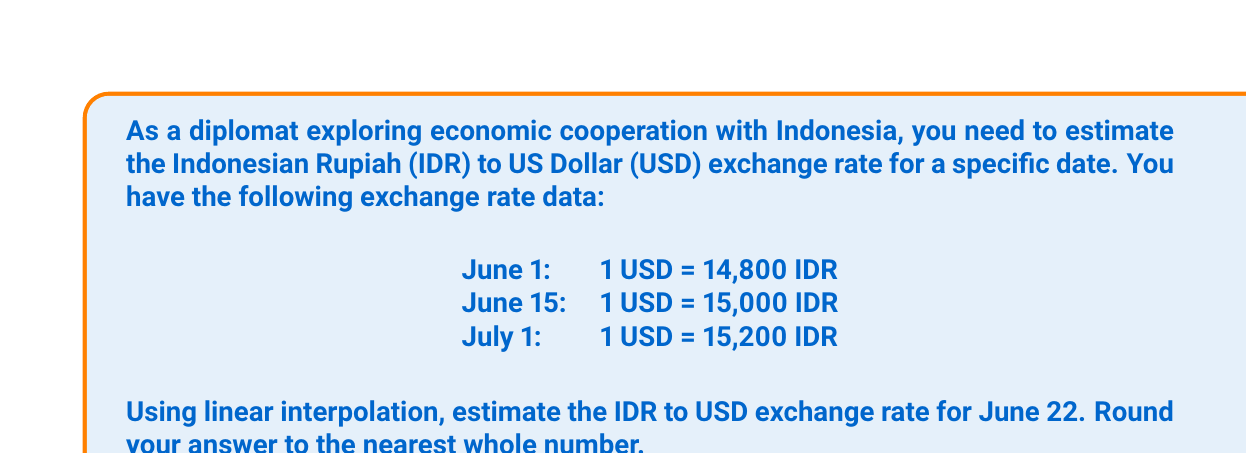Could you help me with this problem? To solve this problem, we'll use linear interpolation. The formula for linear interpolation is:

$$f(x) = f(x_1) + \frac{f(x_2) - f(x_1)}{x_2 - x_1}(x - x_1)$$

Where:
$x$ is the point we're interpolating
$x_1$ and $x_2$ are the known points
$f(x_1)$ and $f(x_2)$ are the function values at $x_1$ and $x_2$

Step 1: Identify the known points
$x_1$ = June 15 (day 15)
$x_2$ = July 1 (day 31)
$f(x_1)$ = 15,000 IDR
$f(x_2)$ = 15,200 IDR

Step 2: Identify the point we're interpolating
$x$ = June 22 (day 22)

Step 3: Apply the linear interpolation formula

$$f(22) = 15000 + \frac{15200 - 15000}{31 - 15}(22 - 15)$$

$$f(22) = 15000 + \frac{200}{16}(7)$$

$$f(22) = 15000 + 12.5(7)$$

$$f(22) = 15000 + 87.5$$

$$f(22) = 15087.5$$

Step 4: Round to the nearest whole number
15,087.5 rounds to 15,088

Therefore, the estimated exchange rate for June 22 is 1 USD = 15,088 IDR.
Answer: 15,088 IDR 